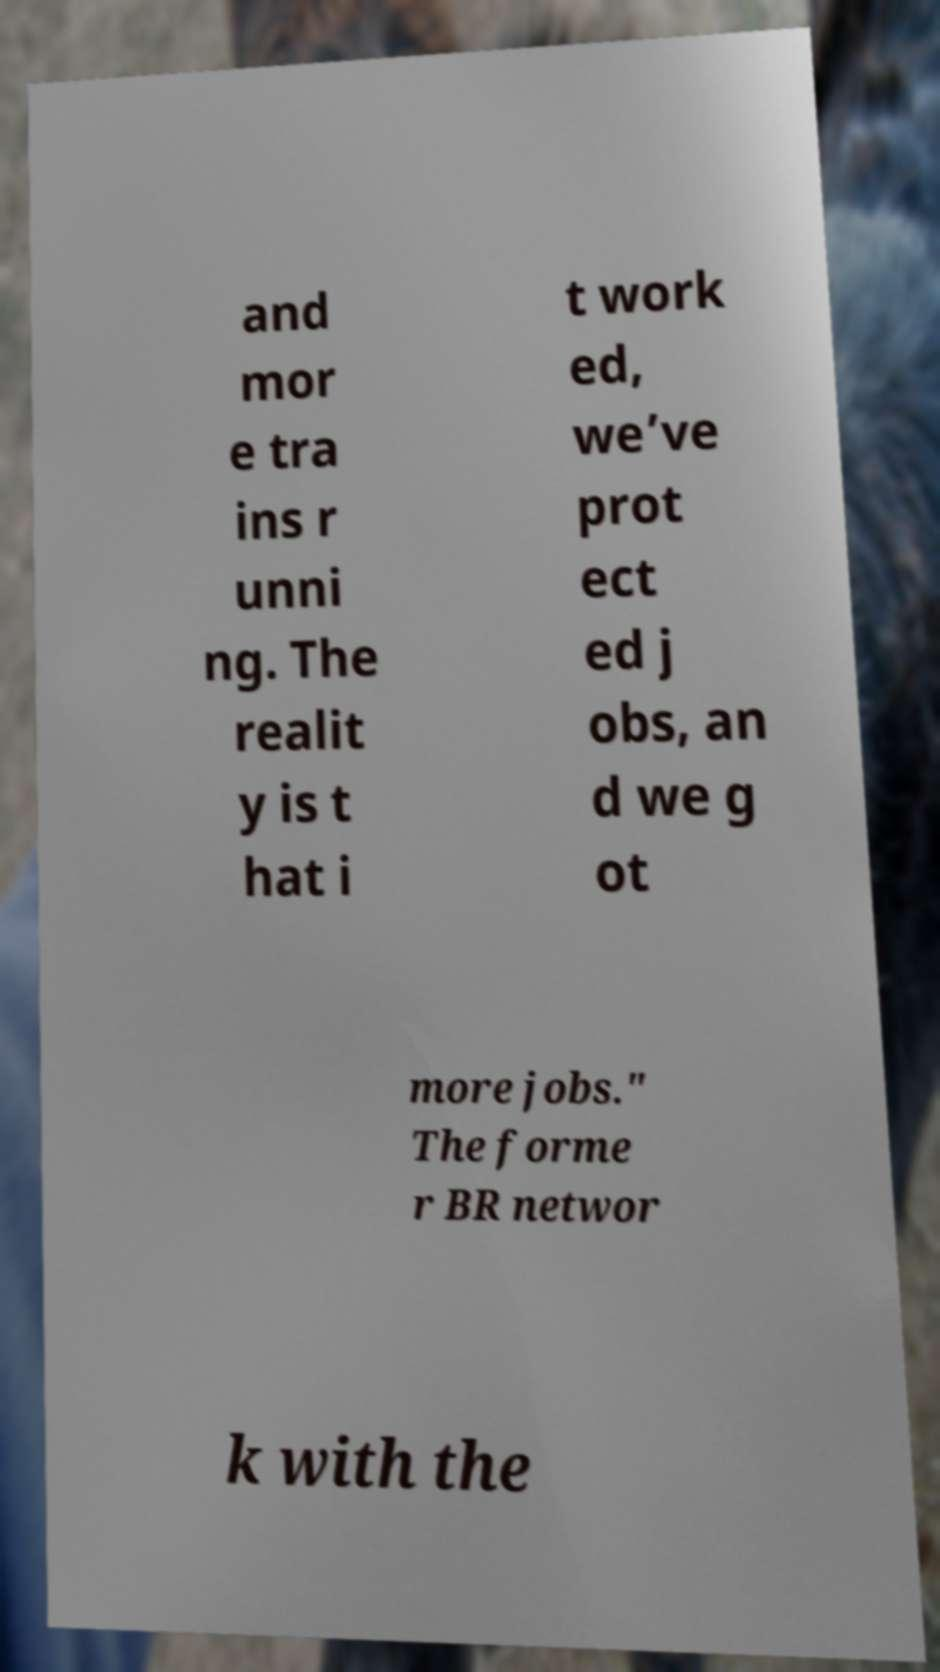For documentation purposes, I need the text within this image transcribed. Could you provide that? and mor e tra ins r unni ng. The realit y is t hat i t work ed, we’ve prot ect ed j obs, an d we g ot more jobs." The forme r BR networ k with the 